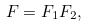Convert formula to latex. <formula><loc_0><loc_0><loc_500><loc_500>F = F _ { 1 } F _ { 2 } ,</formula> 